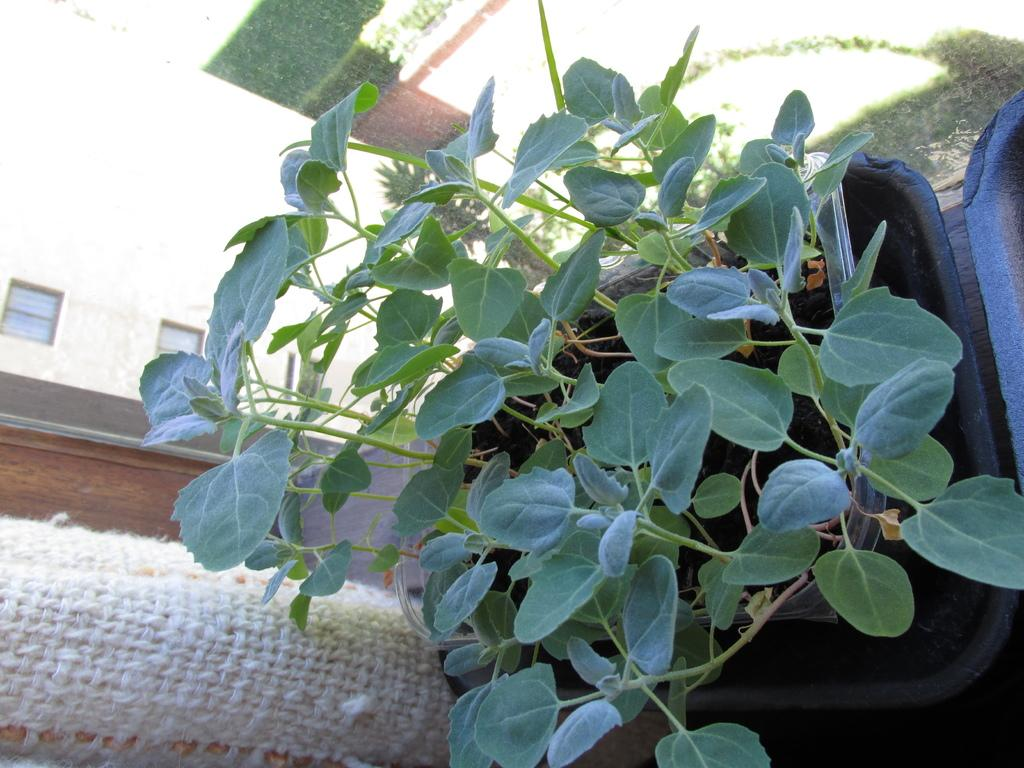What type of plants are in the flower pot in the image? The image contains plants in a flower pot. What color is the cloth on the left side of the image? The cloth on the left side of the image is white. What can be seen in the background of the image? There is a building with windows in the background of the image. What sound can be heard coming from the watch in the image? There is no watch present in the image, so it is not possible to determine what sound might be heard. 